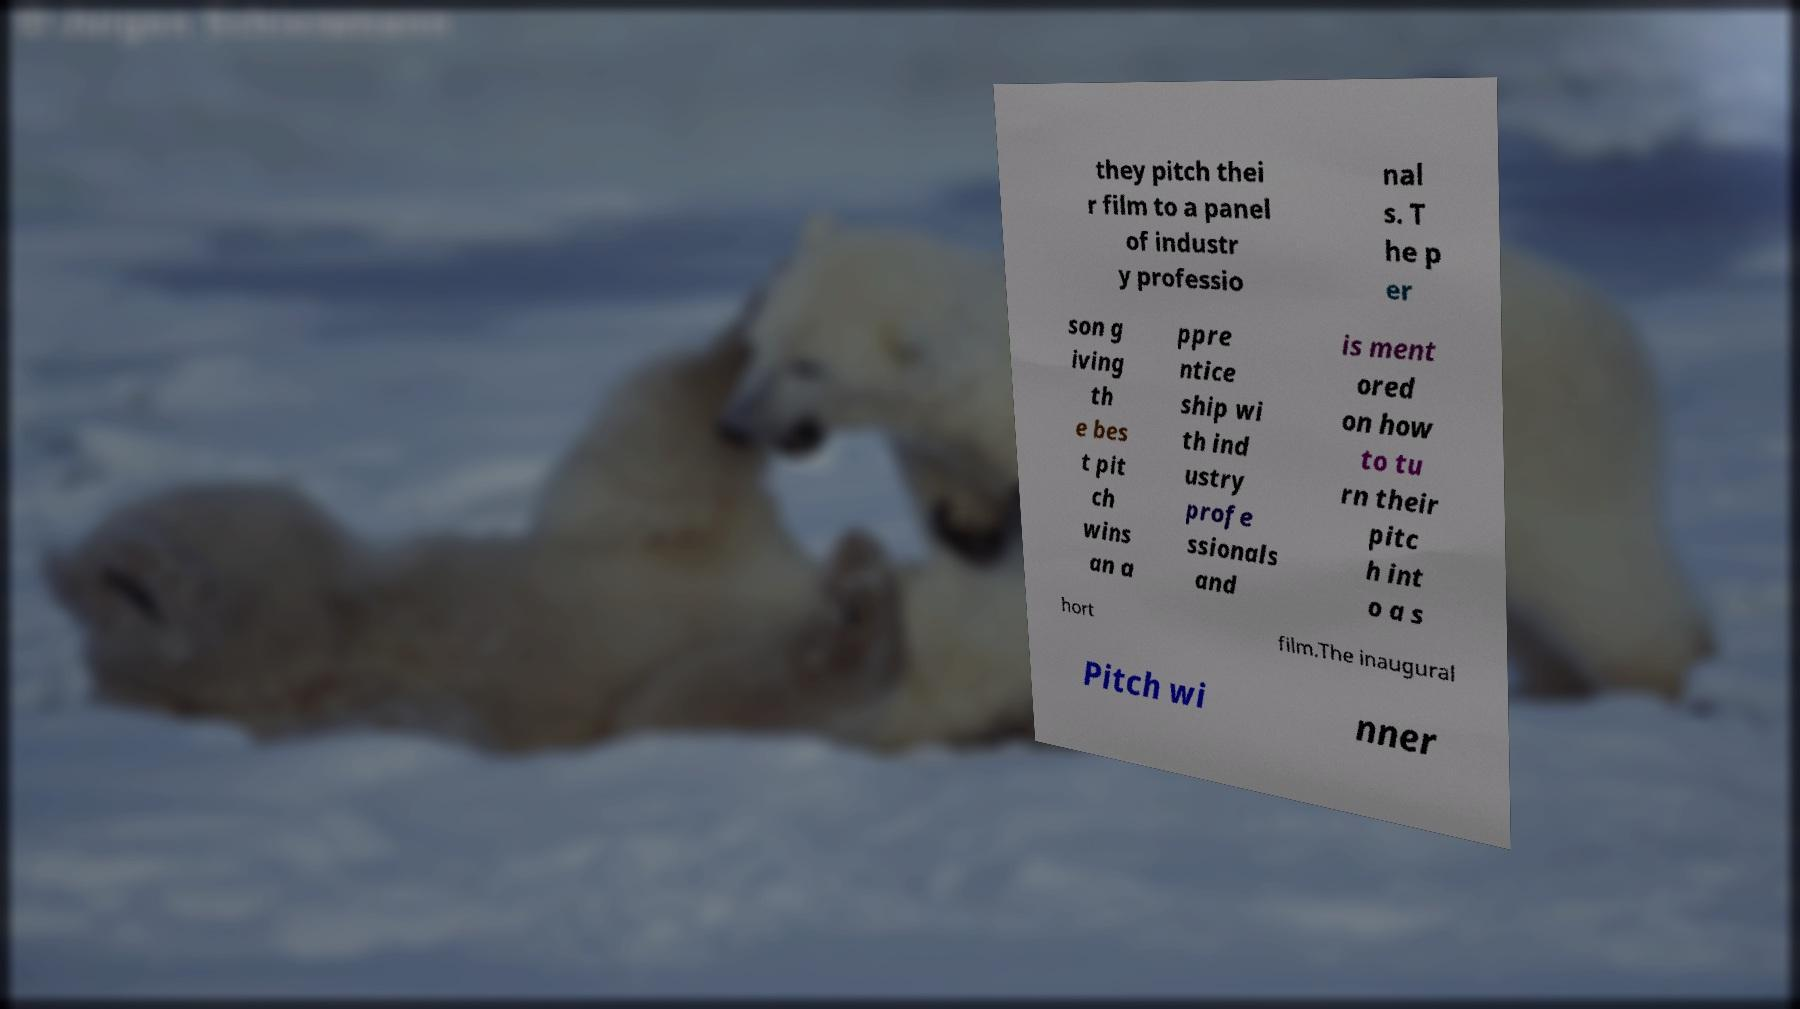I need the written content from this picture converted into text. Can you do that? they pitch thei r film to a panel of industr y professio nal s. T he p er son g iving th e bes t pit ch wins an a ppre ntice ship wi th ind ustry profe ssionals and is ment ored on how to tu rn their pitc h int o a s hort film.The inaugural Pitch wi nner 